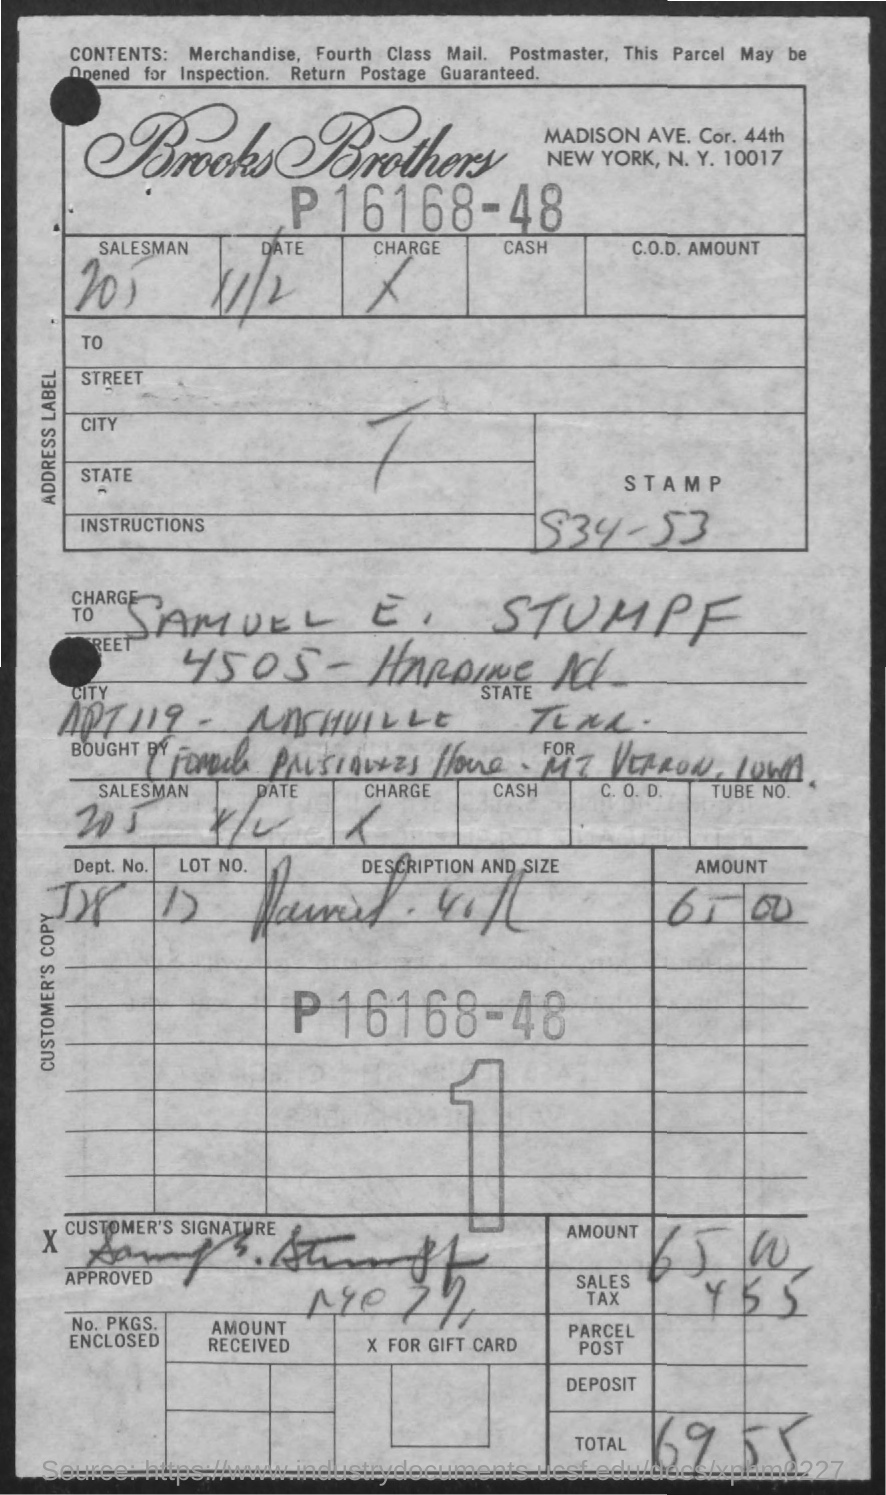What is the date mentioned in the document?
Provide a short and direct response. 11/2. Whose signature is present in the document?
Ensure brevity in your answer.  Samuel E. Stumpf. What is the total amount?
Give a very brief answer. 69 55. What is the Lot number?
Provide a succinct answer. 17. 